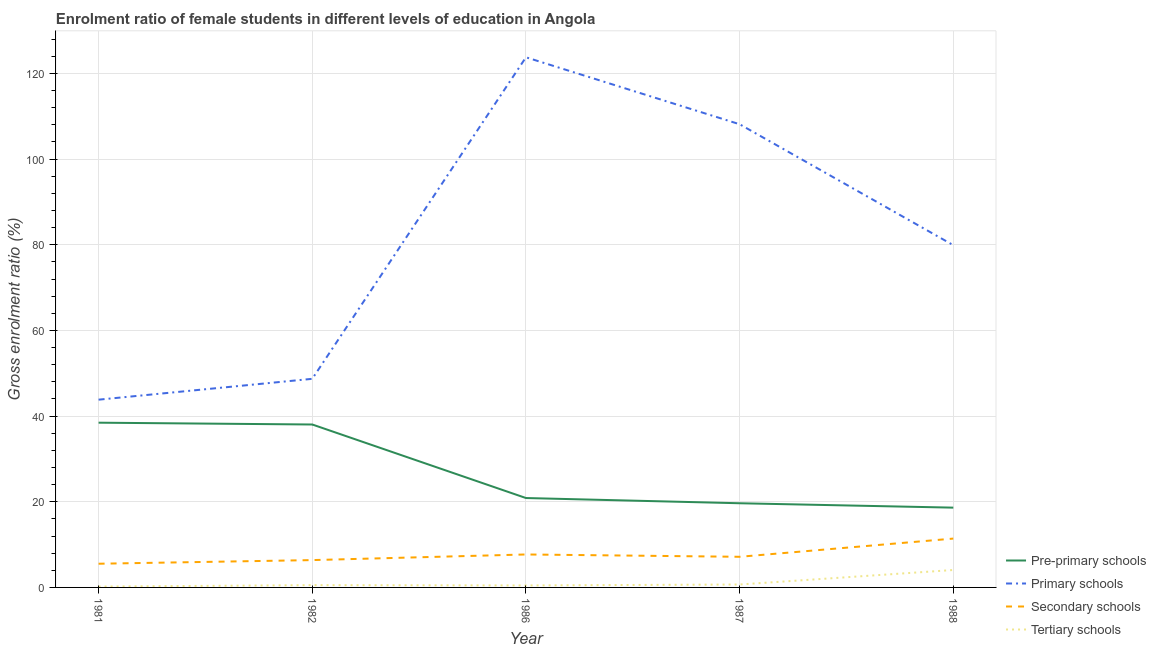Is the number of lines equal to the number of legend labels?
Your answer should be compact. Yes. What is the gross enrolment ratio(male) in secondary schools in 1987?
Your answer should be compact. 7.15. Across all years, what is the maximum gross enrolment ratio(male) in tertiary schools?
Provide a succinct answer. 4.07. Across all years, what is the minimum gross enrolment ratio(male) in pre-primary schools?
Your response must be concise. 18.63. What is the total gross enrolment ratio(male) in primary schools in the graph?
Provide a short and direct response. 404.33. What is the difference between the gross enrolment ratio(male) in primary schools in 1986 and that in 1988?
Your answer should be very brief. 43.86. What is the difference between the gross enrolment ratio(male) in pre-primary schools in 1981 and the gross enrolment ratio(male) in primary schools in 1988?
Provide a succinct answer. -41.44. What is the average gross enrolment ratio(male) in tertiary schools per year?
Your response must be concise. 1.19. In the year 1981, what is the difference between the gross enrolment ratio(male) in pre-primary schools and gross enrolment ratio(male) in secondary schools?
Make the answer very short. 32.93. In how many years, is the gross enrolment ratio(male) in secondary schools greater than 36 %?
Offer a terse response. 0. What is the ratio of the gross enrolment ratio(male) in secondary schools in 1981 to that in 1988?
Keep it short and to the point. 0.49. What is the difference between the highest and the second highest gross enrolment ratio(male) in pre-primary schools?
Provide a short and direct response. 0.42. What is the difference between the highest and the lowest gross enrolment ratio(male) in pre-primary schools?
Your answer should be very brief. 19.83. Is it the case that in every year, the sum of the gross enrolment ratio(male) in tertiary schools and gross enrolment ratio(male) in secondary schools is greater than the sum of gross enrolment ratio(male) in primary schools and gross enrolment ratio(male) in pre-primary schools?
Make the answer very short. Yes. Is the gross enrolment ratio(male) in primary schools strictly less than the gross enrolment ratio(male) in pre-primary schools over the years?
Offer a terse response. No. How many years are there in the graph?
Make the answer very short. 5. What is the difference between two consecutive major ticks on the Y-axis?
Ensure brevity in your answer.  20. Are the values on the major ticks of Y-axis written in scientific E-notation?
Offer a terse response. No. Does the graph contain any zero values?
Your answer should be compact. No. Does the graph contain grids?
Give a very brief answer. Yes. Where does the legend appear in the graph?
Your response must be concise. Bottom right. What is the title of the graph?
Provide a short and direct response. Enrolment ratio of female students in different levels of education in Angola. Does "Compensation of employees" appear as one of the legend labels in the graph?
Your response must be concise. No. What is the label or title of the Y-axis?
Your response must be concise. Gross enrolment ratio (%). What is the Gross enrolment ratio (%) in Pre-primary schools in 1981?
Make the answer very short. 38.46. What is the Gross enrolment ratio (%) in Primary schools in 1981?
Give a very brief answer. 43.83. What is the Gross enrolment ratio (%) of Secondary schools in 1981?
Give a very brief answer. 5.53. What is the Gross enrolment ratio (%) in Tertiary schools in 1981?
Give a very brief answer. 0.2. What is the Gross enrolment ratio (%) in Pre-primary schools in 1982?
Your response must be concise. 38.04. What is the Gross enrolment ratio (%) in Primary schools in 1982?
Give a very brief answer. 48.7. What is the Gross enrolment ratio (%) in Secondary schools in 1982?
Keep it short and to the point. 6.38. What is the Gross enrolment ratio (%) in Tertiary schools in 1982?
Provide a succinct answer. 0.53. What is the Gross enrolment ratio (%) of Pre-primary schools in 1986?
Provide a short and direct response. 20.87. What is the Gross enrolment ratio (%) in Primary schools in 1986?
Your response must be concise. 123.76. What is the Gross enrolment ratio (%) of Secondary schools in 1986?
Offer a very short reply. 7.7. What is the Gross enrolment ratio (%) in Tertiary schools in 1986?
Ensure brevity in your answer.  0.46. What is the Gross enrolment ratio (%) in Pre-primary schools in 1987?
Make the answer very short. 19.65. What is the Gross enrolment ratio (%) of Primary schools in 1987?
Offer a terse response. 108.13. What is the Gross enrolment ratio (%) of Secondary schools in 1987?
Keep it short and to the point. 7.15. What is the Gross enrolment ratio (%) of Tertiary schools in 1987?
Offer a terse response. 0.68. What is the Gross enrolment ratio (%) of Pre-primary schools in 1988?
Your response must be concise. 18.63. What is the Gross enrolment ratio (%) in Primary schools in 1988?
Give a very brief answer. 79.9. What is the Gross enrolment ratio (%) in Secondary schools in 1988?
Offer a very short reply. 11.4. What is the Gross enrolment ratio (%) in Tertiary schools in 1988?
Keep it short and to the point. 4.07. Across all years, what is the maximum Gross enrolment ratio (%) in Pre-primary schools?
Make the answer very short. 38.46. Across all years, what is the maximum Gross enrolment ratio (%) of Primary schools?
Provide a short and direct response. 123.76. Across all years, what is the maximum Gross enrolment ratio (%) of Secondary schools?
Keep it short and to the point. 11.4. Across all years, what is the maximum Gross enrolment ratio (%) of Tertiary schools?
Provide a succinct answer. 4.07. Across all years, what is the minimum Gross enrolment ratio (%) of Pre-primary schools?
Your answer should be very brief. 18.63. Across all years, what is the minimum Gross enrolment ratio (%) of Primary schools?
Provide a short and direct response. 43.83. Across all years, what is the minimum Gross enrolment ratio (%) in Secondary schools?
Your response must be concise. 5.53. Across all years, what is the minimum Gross enrolment ratio (%) in Tertiary schools?
Provide a short and direct response. 0.2. What is the total Gross enrolment ratio (%) of Pre-primary schools in the graph?
Ensure brevity in your answer.  135.64. What is the total Gross enrolment ratio (%) in Primary schools in the graph?
Offer a terse response. 404.33. What is the total Gross enrolment ratio (%) of Secondary schools in the graph?
Offer a terse response. 38.16. What is the total Gross enrolment ratio (%) in Tertiary schools in the graph?
Your response must be concise. 5.95. What is the difference between the Gross enrolment ratio (%) in Pre-primary schools in 1981 and that in 1982?
Provide a succinct answer. 0.42. What is the difference between the Gross enrolment ratio (%) in Primary schools in 1981 and that in 1982?
Ensure brevity in your answer.  -4.87. What is the difference between the Gross enrolment ratio (%) of Secondary schools in 1981 and that in 1982?
Offer a very short reply. -0.85. What is the difference between the Gross enrolment ratio (%) of Tertiary schools in 1981 and that in 1982?
Your answer should be compact. -0.33. What is the difference between the Gross enrolment ratio (%) of Pre-primary schools in 1981 and that in 1986?
Offer a very short reply. 17.59. What is the difference between the Gross enrolment ratio (%) in Primary schools in 1981 and that in 1986?
Keep it short and to the point. -79.93. What is the difference between the Gross enrolment ratio (%) in Secondary schools in 1981 and that in 1986?
Offer a very short reply. -2.16. What is the difference between the Gross enrolment ratio (%) in Tertiary schools in 1981 and that in 1986?
Provide a succinct answer. -0.26. What is the difference between the Gross enrolment ratio (%) of Pre-primary schools in 1981 and that in 1987?
Make the answer very short. 18.81. What is the difference between the Gross enrolment ratio (%) in Primary schools in 1981 and that in 1987?
Your answer should be very brief. -64.3. What is the difference between the Gross enrolment ratio (%) in Secondary schools in 1981 and that in 1987?
Your response must be concise. -1.62. What is the difference between the Gross enrolment ratio (%) in Tertiary schools in 1981 and that in 1987?
Offer a terse response. -0.48. What is the difference between the Gross enrolment ratio (%) of Pre-primary schools in 1981 and that in 1988?
Your answer should be very brief. 19.83. What is the difference between the Gross enrolment ratio (%) in Primary schools in 1981 and that in 1988?
Give a very brief answer. -36.07. What is the difference between the Gross enrolment ratio (%) in Secondary schools in 1981 and that in 1988?
Ensure brevity in your answer.  -5.87. What is the difference between the Gross enrolment ratio (%) of Tertiary schools in 1981 and that in 1988?
Your answer should be compact. -3.87. What is the difference between the Gross enrolment ratio (%) of Pre-primary schools in 1982 and that in 1986?
Offer a terse response. 17.17. What is the difference between the Gross enrolment ratio (%) of Primary schools in 1982 and that in 1986?
Provide a succinct answer. -75.06. What is the difference between the Gross enrolment ratio (%) of Secondary schools in 1982 and that in 1986?
Offer a terse response. -1.31. What is the difference between the Gross enrolment ratio (%) of Tertiary schools in 1982 and that in 1986?
Your response must be concise. 0.07. What is the difference between the Gross enrolment ratio (%) of Pre-primary schools in 1982 and that in 1987?
Your response must be concise. 18.39. What is the difference between the Gross enrolment ratio (%) of Primary schools in 1982 and that in 1987?
Ensure brevity in your answer.  -59.43. What is the difference between the Gross enrolment ratio (%) in Secondary schools in 1982 and that in 1987?
Make the answer very short. -0.77. What is the difference between the Gross enrolment ratio (%) in Tertiary schools in 1982 and that in 1987?
Give a very brief answer. -0.15. What is the difference between the Gross enrolment ratio (%) in Pre-primary schools in 1982 and that in 1988?
Your answer should be very brief. 19.41. What is the difference between the Gross enrolment ratio (%) in Primary schools in 1982 and that in 1988?
Your answer should be very brief. -31.2. What is the difference between the Gross enrolment ratio (%) of Secondary schools in 1982 and that in 1988?
Provide a short and direct response. -5.02. What is the difference between the Gross enrolment ratio (%) of Tertiary schools in 1982 and that in 1988?
Ensure brevity in your answer.  -3.53. What is the difference between the Gross enrolment ratio (%) in Pre-primary schools in 1986 and that in 1987?
Offer a very short reply. 1.22. What is the difference between the Gross enrolment ratio (%) of Primary schools in 1986 and that in 1987?
Your answer should be very brief. 15.63. What is the difference between the Gross enrolment ratio (%) in Secondary schools in 1986 and that in 1987?
Make the answer very short. 0.55. What is the difference between the Gross enrolment ratio (%) in Tertiary schools in 1986 and that in 1987?
Offer a terse response. -0.22. What is the difference between the Gross enrolment ratio (%) in Pre-primary schools in 1986 and that in 1988?
Give a very brief answer. 2.24. What is the difference between the Gross enrolment ratio (%) of Primary schools in 1986 and that in 1988?
Provide a succinct answer. 43.86. What is the difference between the Gross enrolment ratio (%) in Secondary schools in 1986 and that in 1988?
Your response must be concise. -3.71. What is the difference between the Gross enrolment ratio (%) in Tertiary schools in 1986 and that in 1988?
Keep it short and to the point. -3.61. What is the difference between the Gross enrolment ratio (%) in Pre-primary schools in 1987 and that in 1988?
Offer a terse response. 1.02. What is the difference between the Gross enrolment ratio (%) of Primary schools in 1987 and that in 1988?
Provide a short and direct response. 28.23. What is the difference between the Gross enrolment ratio (%) of Secondary schools in 1987 and that in 1988?
Your response must be concise. -4.25. What is the difference between the Gross enrolment ratio (%) in Tertiary schools in 1987 and that in 1988?
Your answer should be compact. -3.38. What is the difference between the Gross enrolment ratio (%) in Pre-primary schools in 1981 and the Gross enrolment ratio (%) in Primary schools in 1982?
Make the answer very short. -10.24. What is the difference between the Gross enrolment ratio (%) of Pre-primary schools in 1981 and the Gross enrolment ratio (%) of Secondary schools in 1982?
Provide a short and direct response. 32.08. What is the difference between the Gross enrolment ratio (%) of Pre-primary schools in 1981 and the Gross enrolment ratio (%) of Tertiary schools in 1982?
Your answer should be very brief. 37.92. What is the difference between the Gross enrolment ratio (%) of Primary schools in 1981 and the Gross enrolment ratio (%) of Secondary schools in 1982?
Provide a succinct answer. 37.45. What is the difference between the Gross enrolment ratio (%) of Primary schools in 1981 and the Gross enrolment ratio (%) of Tertiary schools in 1982?
Your answer should be compact. 43.3. What is the difference between the Gross enrolment ratio (%) of Secondary schools in 1981 and the Gross enrolment ratio (%) of Tertiary schools in 1982?
Offer a very short reply. 5. What is the difference between the Gross enrolment ratio (%) of Pre-primary schools in 1981 and the Gross enrolment ratio (%) of Primary schools in 1986?
Make the answer very short. -85.3. What is the difference between the Gross enrolment ratio (%) of Pre-primary schools in 1981 and the Gross enrolment ratio (%) of Secondary schools in 1986?
Offer a very short reply. 30.76. What is the difference between the Gross enrolment ratio (%) in Pre-primary schools in 1981 and the Gross enrolment ratio (%) in Tertiary schools in 1986?
Offer a terse response. 38. What is the difference between the Gross enrolment ratio (%) in Primary schools in 1981 and the Gross enrolment ratio (%) in Secondary schools in 1986?
Offer a very short reply. 36.14. What is the difference between the Gross enrolment ratio (%) of Primary schools in 1981 and the Gross enrolment ratio (%) of Tertiary schools in 1986?
Give a very brief answer. 43.37. What is the difference between the Gross enrolment ratio (%) of Secondary schools in 1981 and the Gross enrolment ratio (%) of Tertiary schools in 1986?
Give a very brief answer. 5.07. What is the difference between the Gross enrolment ratio (%) in Pre-primary schools in 1981 and the Gross enrolment ratio (%) in Primary schools in 1987?
Make the answer very short. -69.67. What is the difference between the Gross enrolment ratio (%) of Pre-primary schools in 1981 and the Gross enrolment ratio (%) of Secondary schools in 1987?
Your answer should be compact. 31.31. What is the difference between the Gross enrolment ratio (%) of Pre-primary schools in 1981 and the Gross enrolment ratio (%) of Tertiary schools in 1987?
Make the answer very short. 37.77. What is the difference between the Gross enrolment ratio (%) of Primary schools in 1981 and the Gross enrolment ratio (%) of Secondary schools in 1987?
Offer a very short reply. 36.68. What is the difference between the Gross enrolment ratio (%) of Primary schools in 1981 and the Gross enrolment ratio (%) of Tertiary schools in 1987?
Provide a short and direct response. 43.15. What is the difference between the Gross enrolment ratio (%) of Secondary schools in 1981 and the Gross enrolment ratio (%) of Tertiary schools in 1987?
Your answer should be very brief. 4.85. What is the difference between the Gross enrolment ratio (%) in Pre-primary schools in 1981 and the Gross enrolment ratio (%) in Primary schools in 1988?
Make the answer very short. -41.44. What is the difference between the Gross enrolment ratio (%) in Pre-primary schools in 1981 and the Gross enrolment ratio (%) in Secondary schools in 1988?
Offer a very short reply. 27.05. What is the difference between the Gross enrolment ratio (%) in Pre-primary schools in 1981 and the Gross enrolment ratio (%) in Tertiary schools in 1988?
Give a very brief answer. 34.39. What is the difference between the Gross enrolment ratio (%) of Primary schools in 1981 and the Gross enrolment ratio (%) of Secondary schools in 1988?
Offer a terse response. 32.43. What is the difference between the Gross enrolment ratio (%) in Primary schools in 1981 and the Gross enrolment ratio (%) in Tertiary schools in 1988?
Provide a succinct answer. 39.76. What is the difference between the Gross enrolment ratio (%) of Secondary schools in 1981 and the Gross enrolment ratio (%) of Tertiary schools in 1988?
Keep it short and to the point. 1.46. What is the difference between the Gross enrolment ratio (%) of Pre-primary schools in 1982 and the Gross enrolment ratio (%) of Primary schools in 1986?
Provide a succinct answer. -85.73. What is the difference between the Gross enrolment ratio (%) in Pre-primary schools in 1982 and the Gross enrolment ratio (%) in Secondary schools in 1986?
Offer a terse response. 30.34. What is the difference between the Gross enrolment ratio (%) of Pre-primary schools in 1982 and the Gross enrolment ratio (%) of Tertiary schools in 1986?
Offer a terse response. 37.57. What is the difference between the Gross enrolment ratio (%) of Primary schools in 1982 and the Gross enrolment ratio (%) of Secondary schools in 1986?
Keep it short and to the point. 41. What is the difference between the Gross enrolment ratio (%) of Primary schools in 1982 and the Gross enrolment ratio (%) of Tertiary schools in 1986?
Give a very brief answer. 48.24. What is the difference between the Gross enrolment ratio (%) of Secondary schools in 1982 and the Gross enrolment ratio (%) of Tertiary schools in 1986?
Your response must be concise. 5.92. What is the difference between the Gross enrolment ratio (%) in Pre-primary schools in 1982 and the Gross enrolment ratio (%) in Primary schools in 1987?
Provide a short and direct response. -70.1. What is the difference between the Gross enrolment ratio (%) in Pre-primary schools in 1982 and the Gross enrolment ratio (%) in Secondary schools in 1987?
Provide a short and direct response. 30.89. What is the difference between the Gross enrolment ratio (%) of Pre-primary schools in 1982 and the Gross enrolment ratio (%) of Tertiary schools in 1987?
Give a very brief answer. 37.35. What is the difference between the Gross enrolment ratio (%) of Primary schools in 1982 and the Gross enrolment ratio (%) of Secondary schools in 1987?
Keep it short and to the point. 41.55. What is the difference between the Gross enrolment ratio (%) in Primary schools in 1982 and the Gross enrolment ratio (%) in Tertiary schools in 1987?
Give a very brief answer. 48.02. What is the difference between the Gross enrolment ratio (%) in Secondary schools in 1982 and the Gross enrolment ratio (%) in Tertiary schools in 1987?
Your answer should be very brief. 5.7. What is the difference between the Gross enrolment ratio (%) of Pre-primary schools in 1982 and the Gross enrolment ratio (%) of Primary schools in 1988?
Offer a terse response. -41.86. What is the difference between the Gross enrolment ratio (%) of Pre-primary schools in 1982 and the Gross enrolment ratio (%) of Secondary schools in 1988?
Give a very brief answer. 26.63. What is the difference between the Gross enrolment ratio (%) in Pre-primary schools in 1982 and the Gross enrolment ratio (%) in Tertiary schools in 1988?
Give a very brief answer. 33.97. What is the difference between the Gross enrolment ratio (%) of Primary schools in 1982 and the Gross enrolment ratio (%) of Secondary schools in 1988?
Your answer should be compact. 37.3. What is the difference between the Gross enrolment ratio (%) in Primary schools in 1982 and the Gross enrolment ratio (%) in Tertiary schools in 1988?
Your answer should be compact. 44.63. What is the difference between the Gross enrolment ratio (%) in Secondary schools in 1982 and the Gross enrolment ratio (%) in Tertiary schools in 1988?
Offer a terse response. 2.31. What is the difference between the Gross enrolment ratio (%) in Pre-primary schools in 1986 and the Gross enrolment ratio (%) in Primary schools in 1987?
Provide a succinct answer. -87.26. What is the difference between the Gross enrolment ratio (%) in Pre-primary schools in 1986 and the Gross enrolment ratio (%) in Secondary schools in 1987?
Offer a very short reply. 13.72. What is the difference between the Gross enrolment ratio (%) in Pre-primary schools in 1986 and the Gross enrolment ratio (%) in Tertiary schools in 1987?
Provide a short and direct response. 20.19. What is the difference between the Gross enrolment ratio (%) in Primary schools in 1986 and the Gross enrolment ratio (%) in Secondary schools in 1987?
Your answer should be very brief. 116.61. What is the difference between the Gross enrolment ratio (%) of Primary schools in 1986 and the Gross enrolment ratio (%) of Tertiary schools in 1987?
Provide a short and direct response. 123.08. What is the difference between the Gross enrolment ratio (%) in Secondary schools in 1986 and the Gross enrolment ratio (%) in Tertiary schools in 1987?
Provide a succinct answer. 7.01. What is the difference between the Gross enrolment ratio (%) of Pre-primary schools in 1986 and the Gross enrolment ratio (%) of Primary schools in 1988?
Give a very brief answer. -59.03. What is the difference between the Gross enrolment ratio (%) of Pre-primary schools in 1986 and the Gross enrolment ratio (%) of Secondary schools in 1988?
Ensure brevity in your answer.  9.47. What is the difference between the Gross enrolment ratio (%) in Pre-primary schools in 1986 and the Gross enrolment ratio (%) in Tertiary schools in 1988?
Provide a succinct answer. 16.8. What is the difference between the Gross enrolment ratio (%) in Primary schools in 1986 and the Gross enrolment ratio (%) in Secondary schools in 1988?
Offer a very short reply. 112.36. What is the difference between the Gross enrolment ratio (%) of Primary schools in 1986 and the Gross enrolment ratio (%) of Tertiary schools in 1988?
Offer a very short reply. 119.69. What is the difference between the Gross enrolment ratio (%) in Secondary schools in 1986 and the Gross enrolment ratio (%) in Tertiary schools in 1988?
Give a very brief answer. 3.63. What is the difference between the Gross enrolment ratio (%) in Pre-primary schools in 1987 and the Gross enrolment ratio (%) in Primary schools in 1988?
Keep it short and to the point. -60.25. What is the difference between the Gross enrolment ratio (%) in Pre-primary schools in 1987 and the Gross enrolment ratio (%) in Secondary schools in 1988?
Make the answer very short. 8.25. What is the difference between the Gross enrolment ratio (%) in Pre-primary schools in 1987 and the Gross enrolment ratio (%) in Tertiary schools in 1988?
Ensure brevity in your answer.  15.58. What is the difference between the Gross enrolment ratio (%) in Primary schools in 1987 and the Gross enrolment ratio (%) in Secondary schools in 1988?
Offer a very short reply. 96.73. What is the difference between the Gross enrolment ratio (%) in Primary schools in 1987 and the Gross enrolment ratio (%) in Tertiary schools in 1988?
Your answer should be very brief. 104.06. What is the difference between the Gross enrolment ratio (%) in Secondary schools in 1987 and the Gross enrolment ratio (%) in Tertiary schools in 1988?
Provide a short and direct response. 3.08. What is the average Gross enrolment ratio (%) of Pre-primary schools per year?
Your answer should be very brief. 27.13. What is the average Gross enrolment ratio (%) in Primary schools per year?
Your response must be concise. 80.87. What is the average Gross enrolment ratio (%) of Secondary schools per year?
Make the answer very short. 7.63. What is the average Gross enrolment ratio (%) in Tertiary schools per year?
Your response must be concise. 1.19. In the year 1981, what is the difference between the Gross enrolment ratio (%) of Pre-primary schools and Gross enrolment ratio (%) of Primary schools?
Provide a succinct answer. -5.37. In the year 1981, what is the difference between the Gross enrolment ratio (%) in Pre-primary schools and Gross enrolment ratio (%) in Secondary schools?
Your response must be concise. 32.93. In the year 1981, what is the difference between the Gross enrolment ratio (%) in Pre-primary schools and Gross enrolment ratio (%) in Tertiary schools?
Provide a short and direct response. 38.26. In the year 1981, what is the difference between the Gross enrolment ratio (%) of Primary schools and Gross enrolment ratio (%) of Secondary schools?
Your answer should be compact. 38.3. In the year 1981, what is the difference between the Gross enrolment ratio (%) in Primary schools and Gross enrolment ratio (%) in Tertiary schools?
Your answer should be compact. 43.63. In the year 1981, what is the difference between the Gross enrolment ratio (%) of Secondary schools and Gross enrolment ratio (%) of Tertiary schools?
Provide a succinct answer. 5.33. In the year 1982, what is the difference between the Gross enrolment ratio (%) in Pre-primary schools and Gross enrolment ratio (%) in Primary schools?
Make the answer very short. -10.66. In the year 1982, what is the difference between the Gross enrolment ratio (%) of Pre-primary schools and Gross enrolment ratio (%) of Secondary schools?
Provide a succinct answer. 31.66. In the year 1982, what is the difference between the Gross enrolment ratio (%) in Pre-primary schools and Gross enrolment ratio (%) in Tertiary schools?
Ensure brevity in your answer.  37.5. In the year 1982, what is the difference between the Gross enrolment ratio (%) of Primary schools and Gross enrolment ratio (%) of Secondary schools?
Provide a succinct answer. 42.32. In the year 1982, what is the difference between the Gross enrolment ratio (%) of Primary schools and Gross enrolment ratio (%) of Tertiary schools?
Offer a very short reply. 48.17. In the year 1982, what is the difference between the Gross enrolment ratio (%) in Secondary schools and Gross enrolment ratio (%) in Tertiary schools?
Your answer should be compact. 5.85. In the year 1986, what is the difference between the Gross enrolment ratio (%) in Pre-primary schools and Gross enrolment ratio (%) in Primary schools?
Offer a very short reply. -102.89. In the year 1986, what is the difference between the Gross enrolment ratio (%) of Pre-primary schools and Gross enrolment ratio (%) of Secondary schools?
Your answer should be compact. 13.17. In the year 1986, what is the difference between the Gross enrolment ratio (%) in Pre-primary schools and Gross enrolment ratio (%) in Tertiary schools?
Provide a short and direct response. 20.41. In the year 1986, what is the difference between the Gross enrolment ratio (%) of Primary schools and Gross enrolment ratio (%) of Secondary schools?
Provide a short and direct response. 116.07. In the year 1986, what is the difference between the Gross enrolment ratio (%) in Primary schools and Gross enrolment ratio (%) in Tertiary schools?
Ensure brevity in your answer.  123.3. In the year 1986, what is the difference between the Gross enrolment ratio (%) of Secondary schools and Gross enrolment ratio (%) of Tertiary schools?
Keep it short and to the point. 7.23. In the year 1987, what is the difference between the Gross enrolment ratio (%) in Pre-primary schools and Gross enrolment ratio (%) in Primary schools?
Provide a succinct answer. -88.48. In the year 1987, what is the difference between the Gross enrolment ratio (%) of Pre-primary schools and Gross enrolment ratio (%) of Secondary schools?
Offer a very short reply. 12.5. In the year 1987, what is the difference between the Gross enrolment ratio (%) in Pre-primary schools and Gross enrolment ratio (%) in Tertiary schools?
Give a very brief answer. 18.97. In the year 1987, what is the difference between the Gross enrolment ratio (%) of Primary schools and Gross enrolment ratio (%) of Secondary schools?
Make the answer very short. 100.98. In the year 1987, what is the difference between the Gross enrolment ratio (%) of Primary schools and Gross enrolment ratio (%) of Tertiary schools?
Offer a terse response. 107.45. In the year 1987, what is the difference between the Gross enrolment ratio (%) of Secondary schools and Gross enrolment ratio (%) of Tertiary schools?
Provide a succinct answer. 6.47. In the year 1988, what is the difference between the Gross enrolment ratio (%) in Pre-primary schools and Gross enrolment ratio (%) in Primary schools?
Keep it short and to the point. -61.28. In the year 1988, what is the difference between the Gross enrolment ratio (%) in Pre-primary schools and Gross enrolment ratio (%) in Secondary schools?
Provide a short and direct response. 7.22. In the year 1988, what is the difference between the Gross enrolment ratio (%) of Pre-primary schools and Gross enrolment ratio (%) of Tertiary schools?
Your answer should be very brief. 14.56. In the year 1988, what is the difference between the Gross enrolment ratio (%) in Primary schools and Gross enrolment ratio (%) in Secondary schools?
Your answer should be compact. 68.5. In the year 1988, what is the difference between the Gross enrolment ratio (%) of Primary schools and Gross enrolment ratio (%) of Tertiary schools?
Offer a terse response. 75.83. In the year 1988, what is the difference between the Gross enrolment ratio (%) of Secondary schools and Gross enrolment ratio (%) of Tertiary schools?
Your answer should be very brief. 7.33. What is the ratio of the Gross enrolment ratio (%) of Pre-primary schools in 1981 to that in 1982?
Make the answer very short. 1.01. What is the ratio of the Gross enrolment ratio (%) in Primary schools in 1981 to that in 1982?
Provide a succinct answer. 0.9. What is the ratio of the Gross enrolment ratio (%) of Secondary schools in 1981 to that in 1982?
Your response must be concise. 0.87. What is the ratio of the Gross enrolment ratio (%) of Tertiary schools in 1981 to that in 1982?
Provide a short and direct response. 0.38. What is the ratio of the Gross enrolment ratio (%) in Pre-primary schools in 1981 to that in 1986?
Your answer should be very brief. 1.84. What is the ratio of the Gross enrolment ratio (%) in Primary schools in 1981 to that in 1986?
Offer a very short reply. 0.35. What is the ratio of the Gross enrolment ratio (%) in Secondary schools in 1981 to that in 1986?
Make the answer very short. 0.72. What is the ratio of the Gross enrolment ratio (%) of Tertiary schools in 1981 to that in 1986?
Your answer should be very brief. 0.44. What is the ratio of the Gross enrolment ratio (%) in Pre-primary schools in 1981 to that in 1987?
Provide a succinct answer. 1.96. What is the ratio of the Gross enrolment ratio (%) of Primary schools in 1981 to that in 1987?
Your answer should be very brief. 0.41. What is the ratio of the Gross enrolment ratio (%) in Secondary schools in 1981 to that in 1987?
Your answer should be very brief. 0.77. What is the ratio of the Gross enrolment ratio (%) in Tertiary schools in 1981 to that in 1987?
Offer a terse response. 0.3. What is the ratio of the Gross enrolment ratio (%) of Pre-primary schools in 1981 to that in 1988?
Give a very brief answer. 2.06. What is the ratio of the Gross enrolment ratio (%) in Primary schools in 1981 to that in 1988?
Offer a terse response. 0.55. What is the ratio of the Gross enrolment ratio (%) in Secondary schools in 1981 to that in 1988?
Ensure brevity in your answer.  0.49. What is the ratio of the Gross enrolment ratio (%) in Tertiary schools in 1981 to that in 1988?
Keep it short and to the point. 0.05. What is the ratio of the Gross enrolment ratio (%) of Pre-primary schools in 1982 to that in 1986?
Your answer should be very brief. 1.82. What is the ratio of the Gross enrolment ratio (%) of Primary schools in 1982 to that in 1986?
Make the answer very short. 0.39. What is the ratio of the Gross enrolment ratio (%) of Secondary schools in 1982 to that in 1986?
Provide a succinct answer. 0.83. What is the ratio of the Gross enrolment ratio (%) of Tertiary schools in 1982 to that in 1986?
Ensure brevity in your answer.  1.16. What is the ratio of the Gross enrolment ratio (%) of Pre-primary schools in 1982 to that in 1987?
Provide a succinct answer. 1.94. What is the ratio of the Gross enrolment ratio (%) of Primary schools in 1982 to that in 1987?
Provide a short and direct response. 0.45. What is the ratio of the Gross enrolment ratio (%) of Secondary schools in 1982 to that in 1987?
Offer a very short reply. 0.89. What is the ratio of the Gross enrolment ratio (%) in Tertiary schools in 1982 to that in 1987?
Offer a very short reply. 0.78. What is the ratio of the Gross enrolment ratio (%) in Pre-primary schools in 1982 to that in 1988?
Offer a terse response. 2.04. What is the ratio of the Gross enrolment ratio (%) of Primary schools in 1982 to that in 1988?
Give a very brief answer. 0.61. What is the ratio of the Gross enrolment ratio (%) in Secondary schools in 1982 to that in 1988?
Offer a terse response. 0.56. What is the ratio of the Gross enrolment ratio (%) of Tertiary schools in 1982 to that in 1988?
Give a very brief answer. 0.13. What is the ratio of the Gross enrolment ratio (%) in Pre-primary schools in 1986 to that in 1987?
Provide a succinct answer. 1.06. What is the ratio of the Gross enrolment ratio (%) in Primary schools in 1986 to that in 1987?
Make the answer very short. 1.14. What is the ratio of the Gross enrolment ratio (%) of Secondary schools in 1986 to that in 1987?
Your response must be concise. 1.08. What is the ratio of the Gross enrolment ratio (%) of Tertiary schools in 1986 to that in 1987?
Give a very brief answer. 0.68. What is the ratio of the Gross enrolment ratio (%) of Pre-primary schools in 1986 to that in 1988?
Give a very brief answer. 1.12. What is the ratio of the Gross enrolment ratio (%) of Primary schools in 1986 to that in 1988?
Give a very brief answer. 1.55. What is the ratio of the Gross enrolment ratio (%) of Secondary schools in 1986 to that in 1988?
Provide a succinct answer. 0.67. What is the ratio of the Gross enrolment ratio (%) of Tertiary schools in 1986 to that in 1988?
Provide a short and direct response. 0.11. What is the ratio of the Gross enrolment ratio (%) of Pre-primary schools in 1987 to that in 1988?
Your answer should be compact. 1.05. What is the ratio of the Gross enrolment ratio (%) in Primary schools in 1987 to that in 1988?
Provide a succinct answer. 1.35. What is the ratio of the Gross enrolment ratio (%) of Secondary schools in 1987 to that in 1988?
Keep it short and to the point. 0.63. What is the ratio of the Gross enrolment ratio (%) in Tertiary schools in 1987 to that in 1988?
Provide a succinct answer. 0.17. What is the difference between the highest and the second highest Gross enrolment ratio (%) of Pre-primary schools?
Your response must be concise. 0.42. What is the difference between the highest and the second highest Gross enrolment ratio (%) of Primary schools?
Offer a terse response. 15.63. What is the difference between the highest and the second highest Gross enrolment ratio (%) in Secondary schools?
Your response must be concise. 3.71. What is the difference between the highest and the second highest Gross enrolment ratio (%) in Tertiary schools?
Ensure brevity in your answer.  3.38. What is the difference between the highest and the lowest Gross enrolment ratio (%) of Pre-primary schools?
Offer a very short reply. 19.83. What is the difference between the highest and the lowest Gross enrolment ratio (%) in Primary schools?
Ensure brevity in your answer.  79.93. What is the difference between the highest and the lowest Gross enrolment ratio (%) of Secondary schools?
Ensure brevity in your answer.  5.87. What is the difference between the highest and the lowest Gross enrolment ratio (%) in Tertiary schools?
Provide a short and direct response. 3.87. 